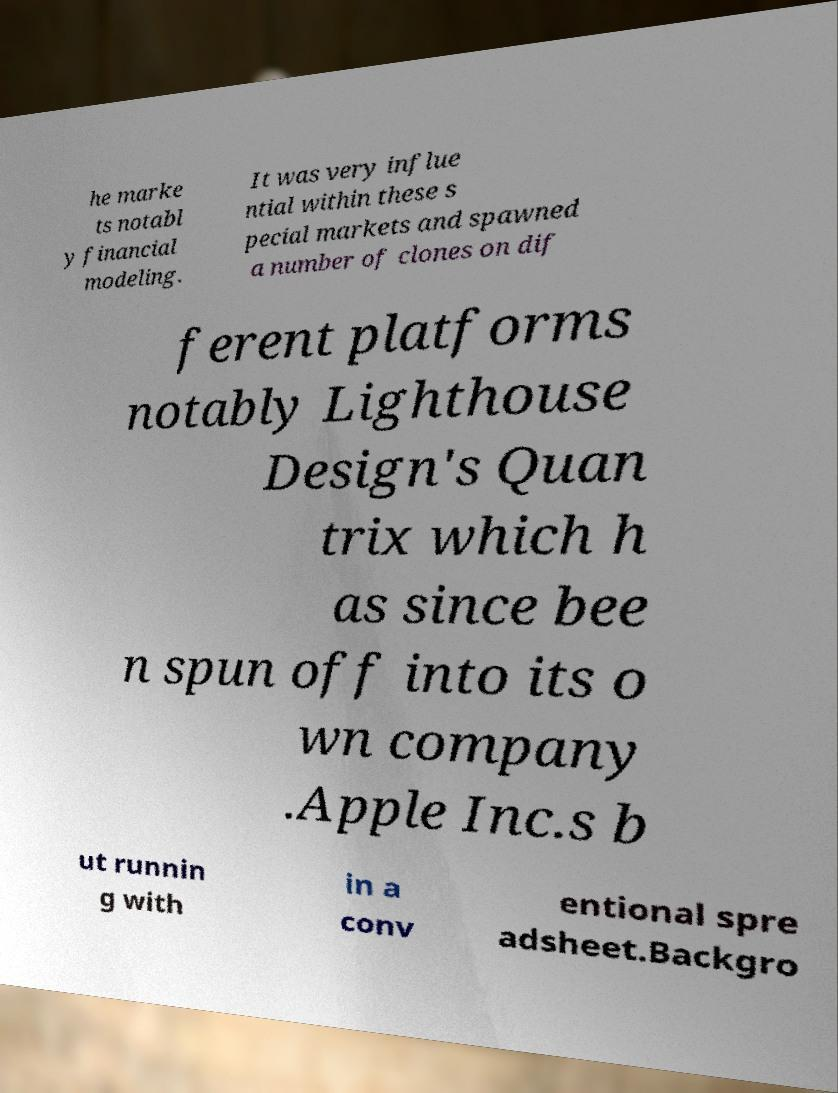Could you assist in decoding the text presented in this image and type it out clearly? he marke ts notabl y financial modeling. It was very influe ntial within these s pecial markets and spawned a number of clones on dif ferent platforms notably Lighthouse Design's Quan trix which h as since bee n spun off into its o wn company .Apple Inc.s b ut runnin g with in a conv entional spre adsheet.Backgro 